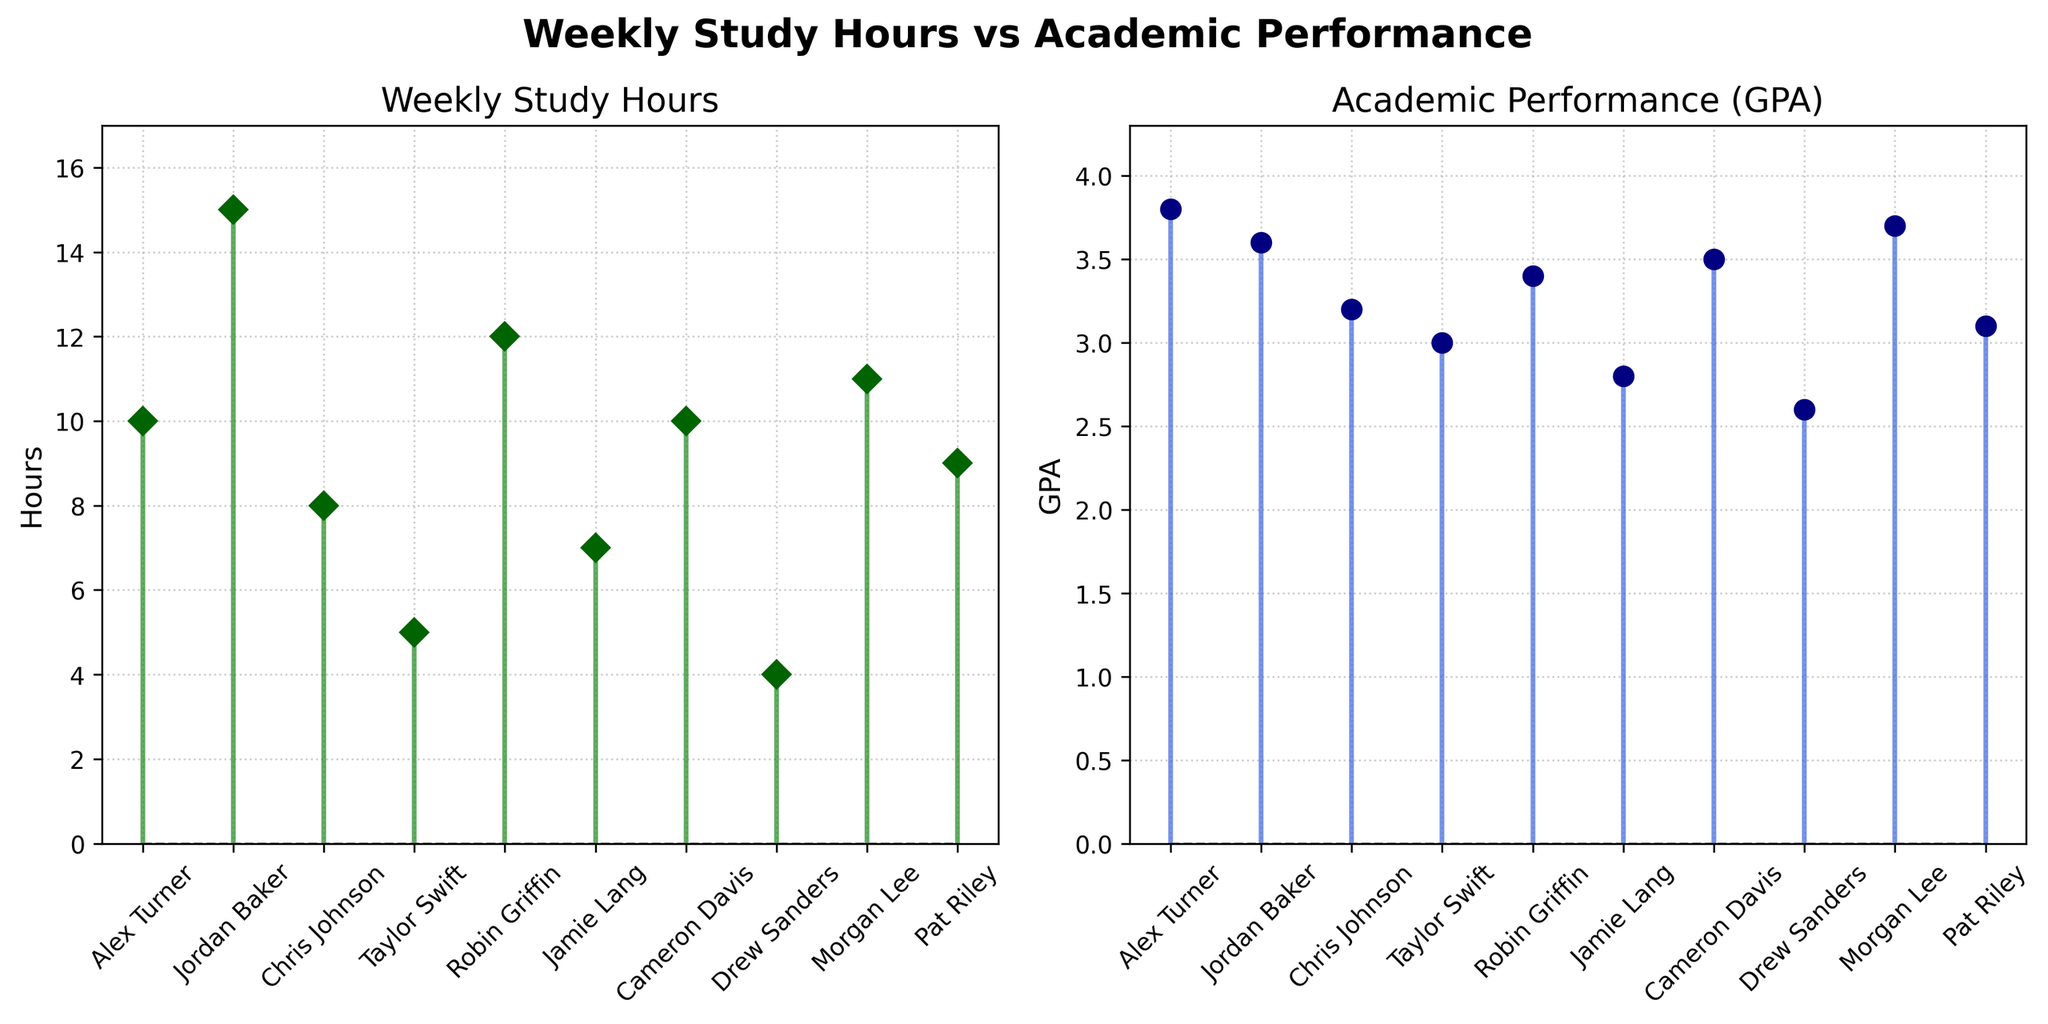What does the title of the figure say? The title is found at the top center of the figure. It clearly states the subject of the plots.
Answer: "Weekly Study Hours vs Academic Performance" How many students are represented in the figure? The number of students can be determined by counting the data points or names on the x-axis of either subplot.
Answer: 10 What's the color of the stem lines for Weekly Study Hours? The color of the stem lines for Weekly Study Hours is evident from the corresponding subplot's visual appearance.
Answer: forestgreen Which student has the highest GPA? By examining the subplot for Academic Performance (GPA), one can identify the tallest stem indicating the highest GPA.
Answer: Alex Turner Compare the Weekly Study Hours of Jordan Baker and Robin Griffin. Who studies more and by how many hours? From the Weekly Study Hours subplot, Jordan Baker and Robin Griffin's markers can be checked and compared. Jordan studies 15 hours; Robin studies 12 hours.
Answer: Jordan Baker, 3 hours What's the difference between the highest and the lowest GPA? Identify the highest GPA (3.8) and the lowest GPA (2.6) from the Academic Performance subplot and subtract the latter from the former.
Answer: 1.2 What is the median Weekly Study Hours value? Order the Weekly Study Hours values: [4, 5, 7, 8, 9, 10, 10, 11, 12, 15]. The median is the average of the 5th and 6th values.
Answer: 9.5 Which student has the lowest Weekly Study Hours and what is their GPA? The shortest stem in the Weekly Study Hours subplot indicates the student with the lowest study hours (Drew Sanders with 4 hours) and their GPA (2.6).
Answer: Drew Sanders, 2.6 Is there a clear visual correlation between Weekly Study Hours and Academic Performance (GPA)? By comparing the heights of stems across both subplots, one can determine if higher study hours generally correspond to higher GPAs. The overall trend should be assessed visually.
Answer: Yes, generally more study hours correlate with higher GPA Is there any student who has the same value for Weekly Study Hours and GPA? Check both subplots for any student whose Weekly Study Hours' value matches their GPA.
Answer: No 